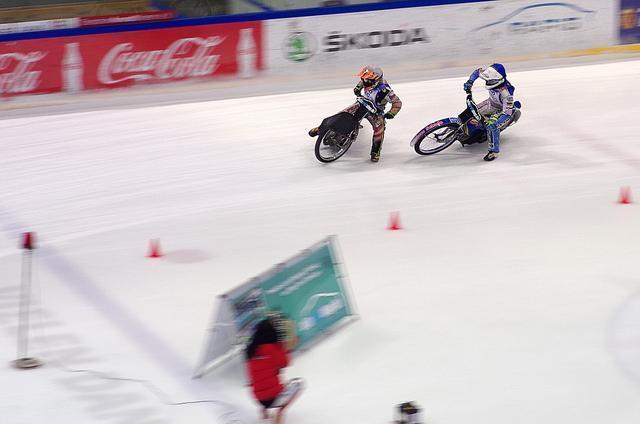How many motorcycles can be seen?
Give a very brief answer. 2. How many people can be seen?
Give a very brief answer. 3. How many horses are pulling the carriage?
Give a very brief answer. 0. 